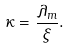Convert formula to latex. <formula><loc_0><loc_0><loc_500><loc_500>\kappa = \frac { \lambda _ { m } } { \xi } .</formula> 